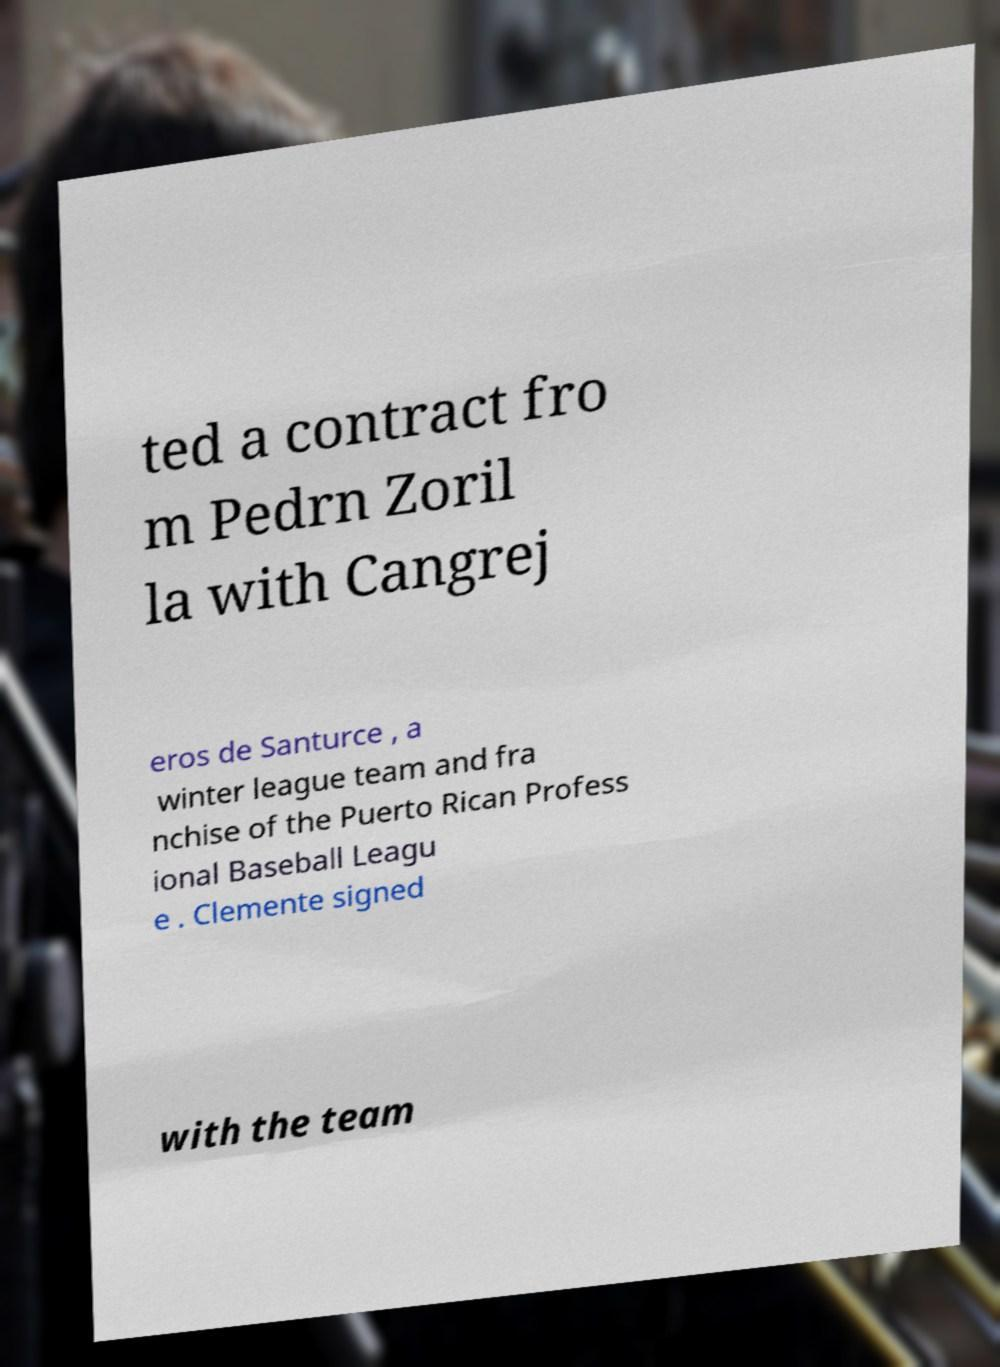For documentation purposes, I need the text within this image transcribed. Could you provide that? ted a contract fro m Pedrn Zoril la with Cangrej eros de Santurce , a winter league team and fra nchise of the Puerto Rican Profess ional Baseball Leagu e . Clemente signed with the team 